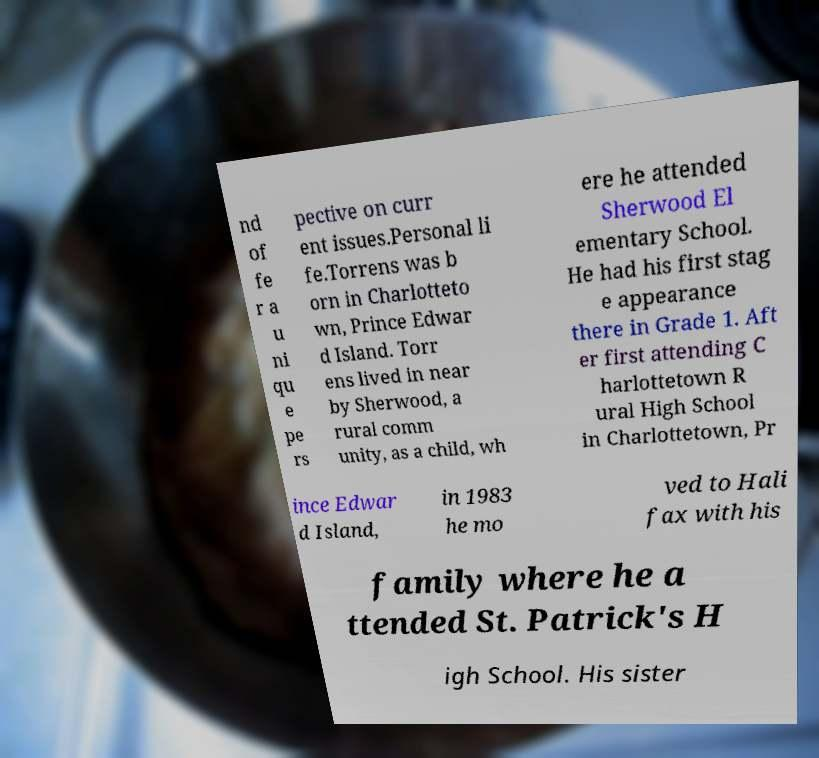What messages or text are displayed in this image? I need them in a readable, typed format. nd of fe r a u ni qu e pe rs pective on curr ent issues.Personal li fe.Torrens was b orn in Charlotteto wn, Prince Edwar d Island. Torr ens lived in near by Sherwood, a rural comm unity, as a child, wh ere he attended Sherwood El ementary School. He had his first stag e appearance there in Grade 1. Aft er first attending C harlottetown R ural High School in Charlottetown, Pr ince Edwar d Island, in 1983 he mo ved to Hali fax with his family where he a ttended St. Patrick's H igh School. His sister 